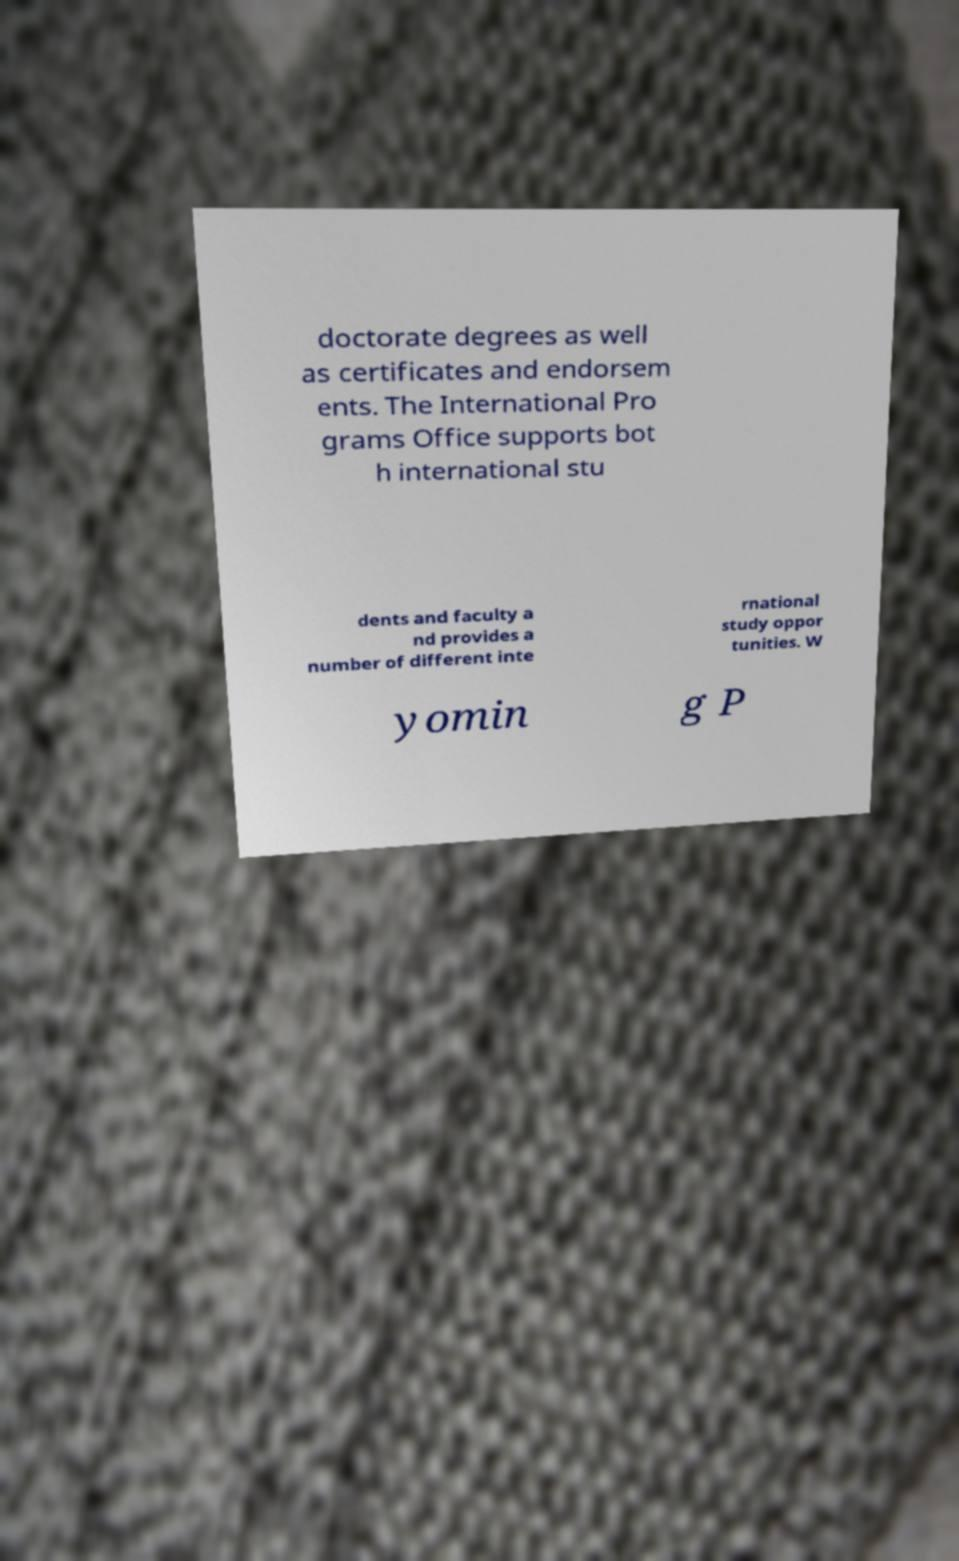Could you extract and type out the text from this image? doctorate degrees as well as certificates and endorsem ents. The International Pro grams Office supports bot h international stu dents and faculty a nd provides a number of different inte rnational study oppor tunities. W yomin g P 